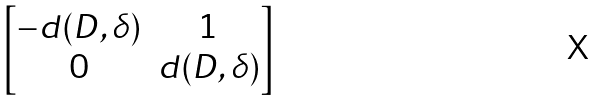<formula> <loc_0><loc_0><loc_500><loc_500>\begin{bmatrix} - d ( D , \delta ) & 1 \\ 0 & d ( D , \delta ) \end{bmatrix}</formula> 